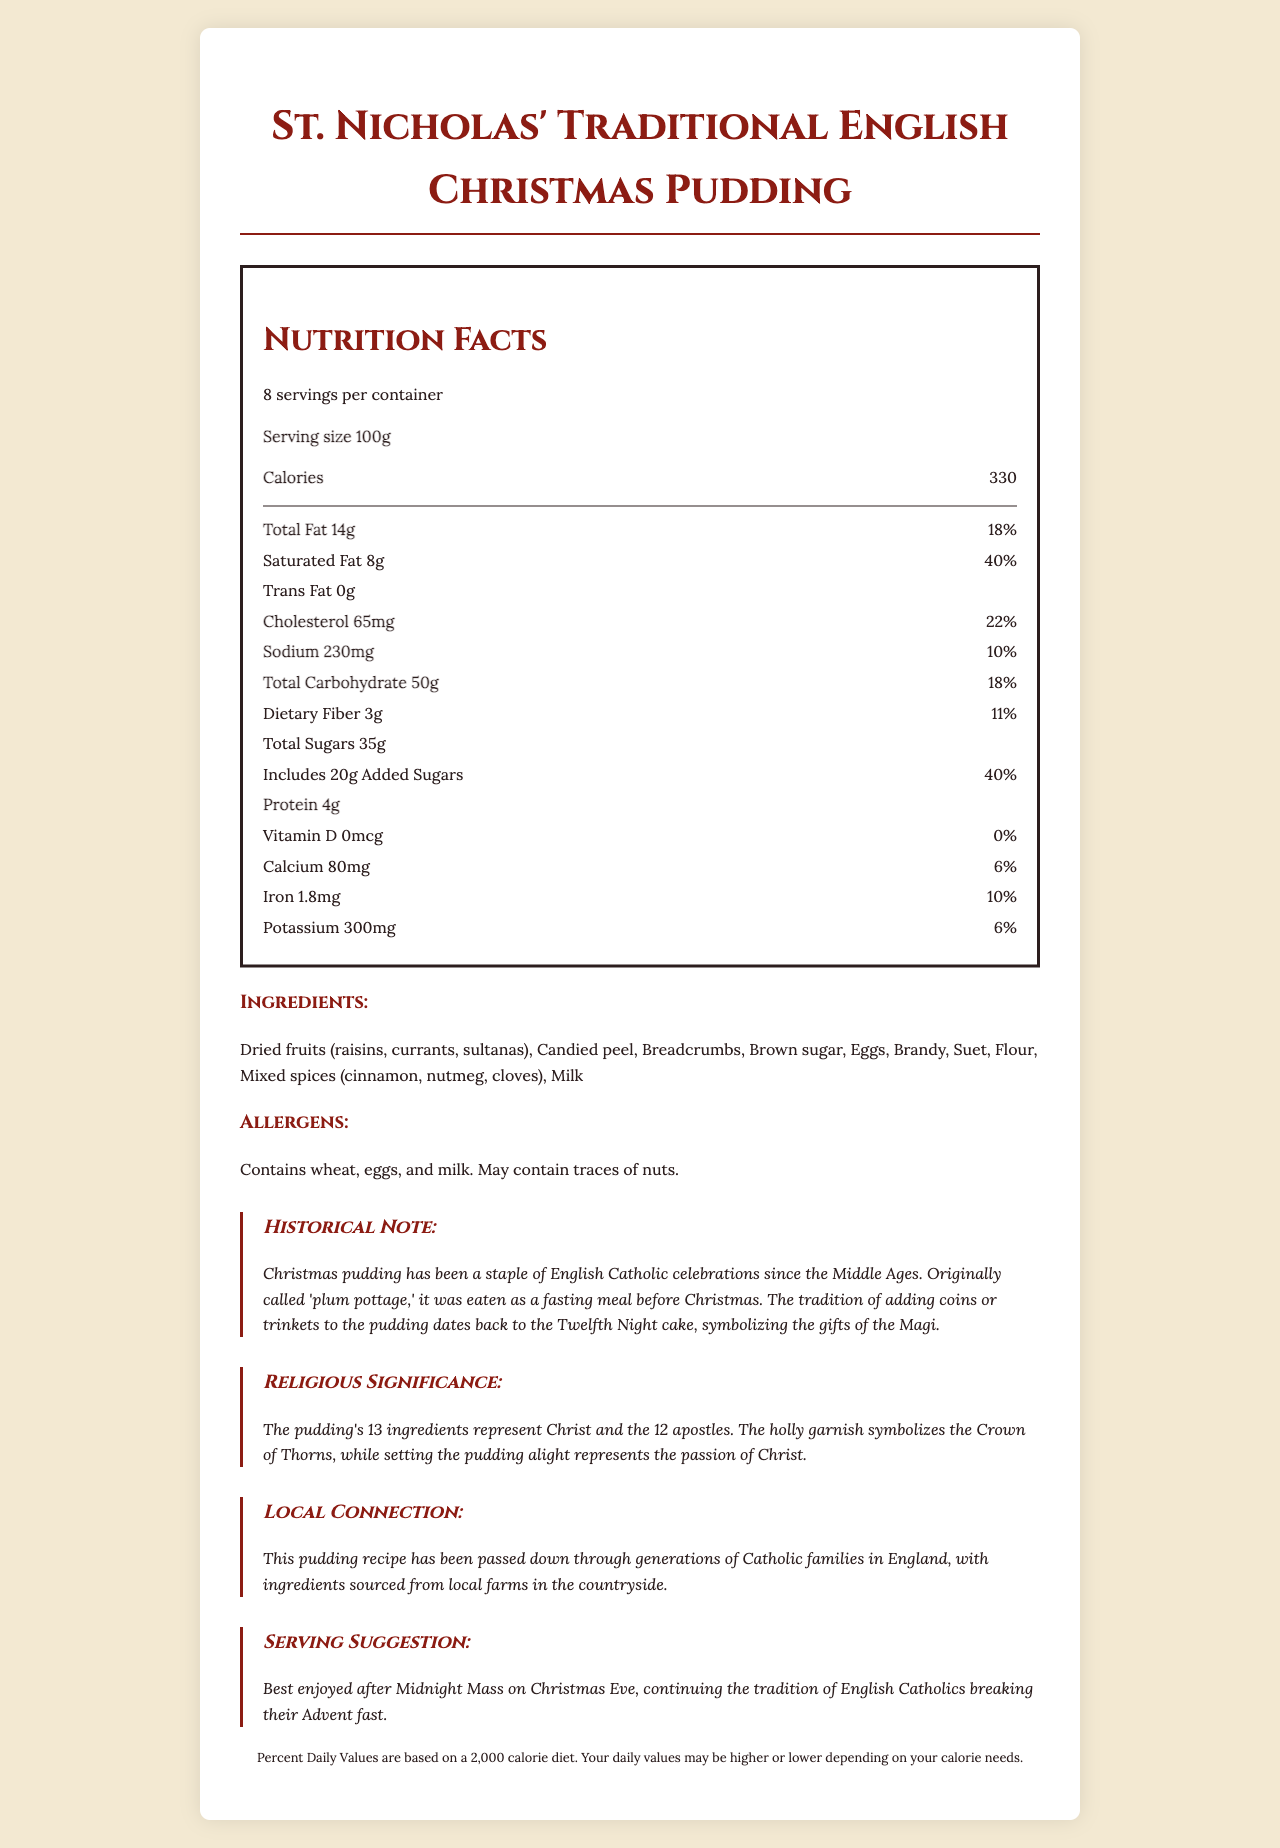who is the product named after? The product is named "St. Nicholas' Traditional English Christmas Pudding," indicating it is named after St. Nicholas.
Answer: St. Nicholas what is the serving size of the pudding? The serving size is listed as 100g in the nutrition facts section.
Answer: 100g how many servings are in one container? The document specifies that there are 8 servings per container.
Answer: 8 servings what are the total calories per serving? The nutrition facts indicate that there are 330 calories per serving.
Answer: 330 calories what is the dietary fiber content per serving? The dietary fiber content per serving is specified as 3g.
Answer: 3g what is the percent daily value of saturated fat? The document mentions that the saturated fat contributes to 40% of the daily value.
Answer: 40% which ingredient in the pudding symbolizes the Crown of Thorns? A. Brandy B. Holly garnish C. Suet D. Raisins The holly garnish symbolizes the Crown of Thorns, as stated in the religious significance section.
Answer: B what is the religious significance of setting the pudding alight? A. Symbolizes the passion of Christ B. Represents the gifts of the Magi C. Stands for the Crown of Thorns D. Denotes the Twelve Apostles Setting the pudding alight represents the passion of Christ, as per the religious significance section.
Answer: A does the pudding contain nuts? The allergens section states that the pudding may contain traces of nuts.
Answer: May contain traces of nuts what historical tradition is connected to adding coins to the pudding? The historical note mentions that the tradition of adding coins dates back to the Twelfth Night cake, symbolizing the gifts of the Magi.
Answer: Twelfth Night cake summarize the main idea of the document. The document is comprehensive covering nutritional details, the tradition and religious significance behind the pudding, and its importance in Catholic heritage as well as practical serving suggestions.
Answer: The document provides detailed nutrition facts, ingredients, allergen information, and historical, religious, and local connections of St. Nicholas' Traditional English Christmas Pudding. It highlights its importance in Catholic celebrations and offers serving suggestions. what are the local farm-sourced ingredients in the pudding? The document mentions that ingredients are sourced from local farms but does not specify which ones are locally sourced.
Answer: Cannot be determined what is the cholesterol amount per serving? The cholesterol amount per serving is listed as 65mg.
Answer: 65mg how much protein is in one serving of the pudding? The protein content per serving is specified as 4g.
Answer: 4g what tradition is associated with enjoying the pudding after Midnight Mass? The serving suggestion states the tradition of enjoying the pudding after Midnight Mass is linked with breaking the Advent fast for English Catholics.
Answer: Breaking the Advent fast how many grams of added sugars are in one serving? The added sugars amount per serving is specified as 20g.
Answer: 20g what percentage of the daily value does sodium contribute? The nutrition facts indicate that the sodium content per serving contributes to 10% of the daily value.
Answer: 10% 